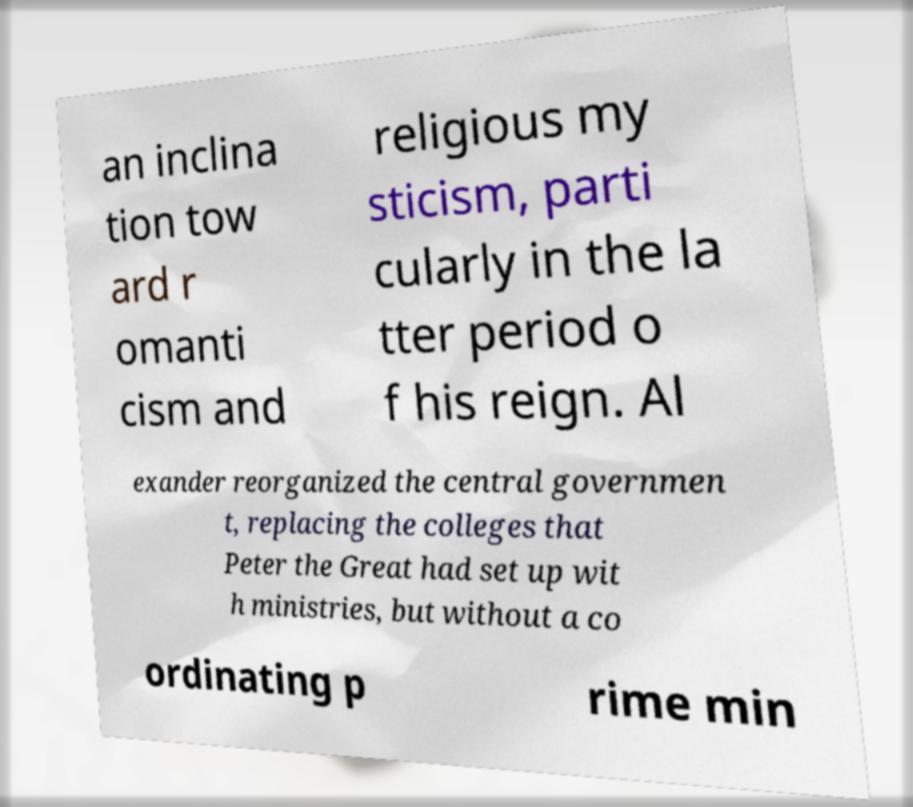For documentation purposes, I need the text within this image transcribed. Could you provide that? an inclina tion tow ard r omanti cism and religious my sticism, parti cularly in the la tter period o f his reign. Al exander reorganized the central governmen t, replacing the colleges that Peter the Great had set up wit h ministries, but without a co ordinating p rime min 